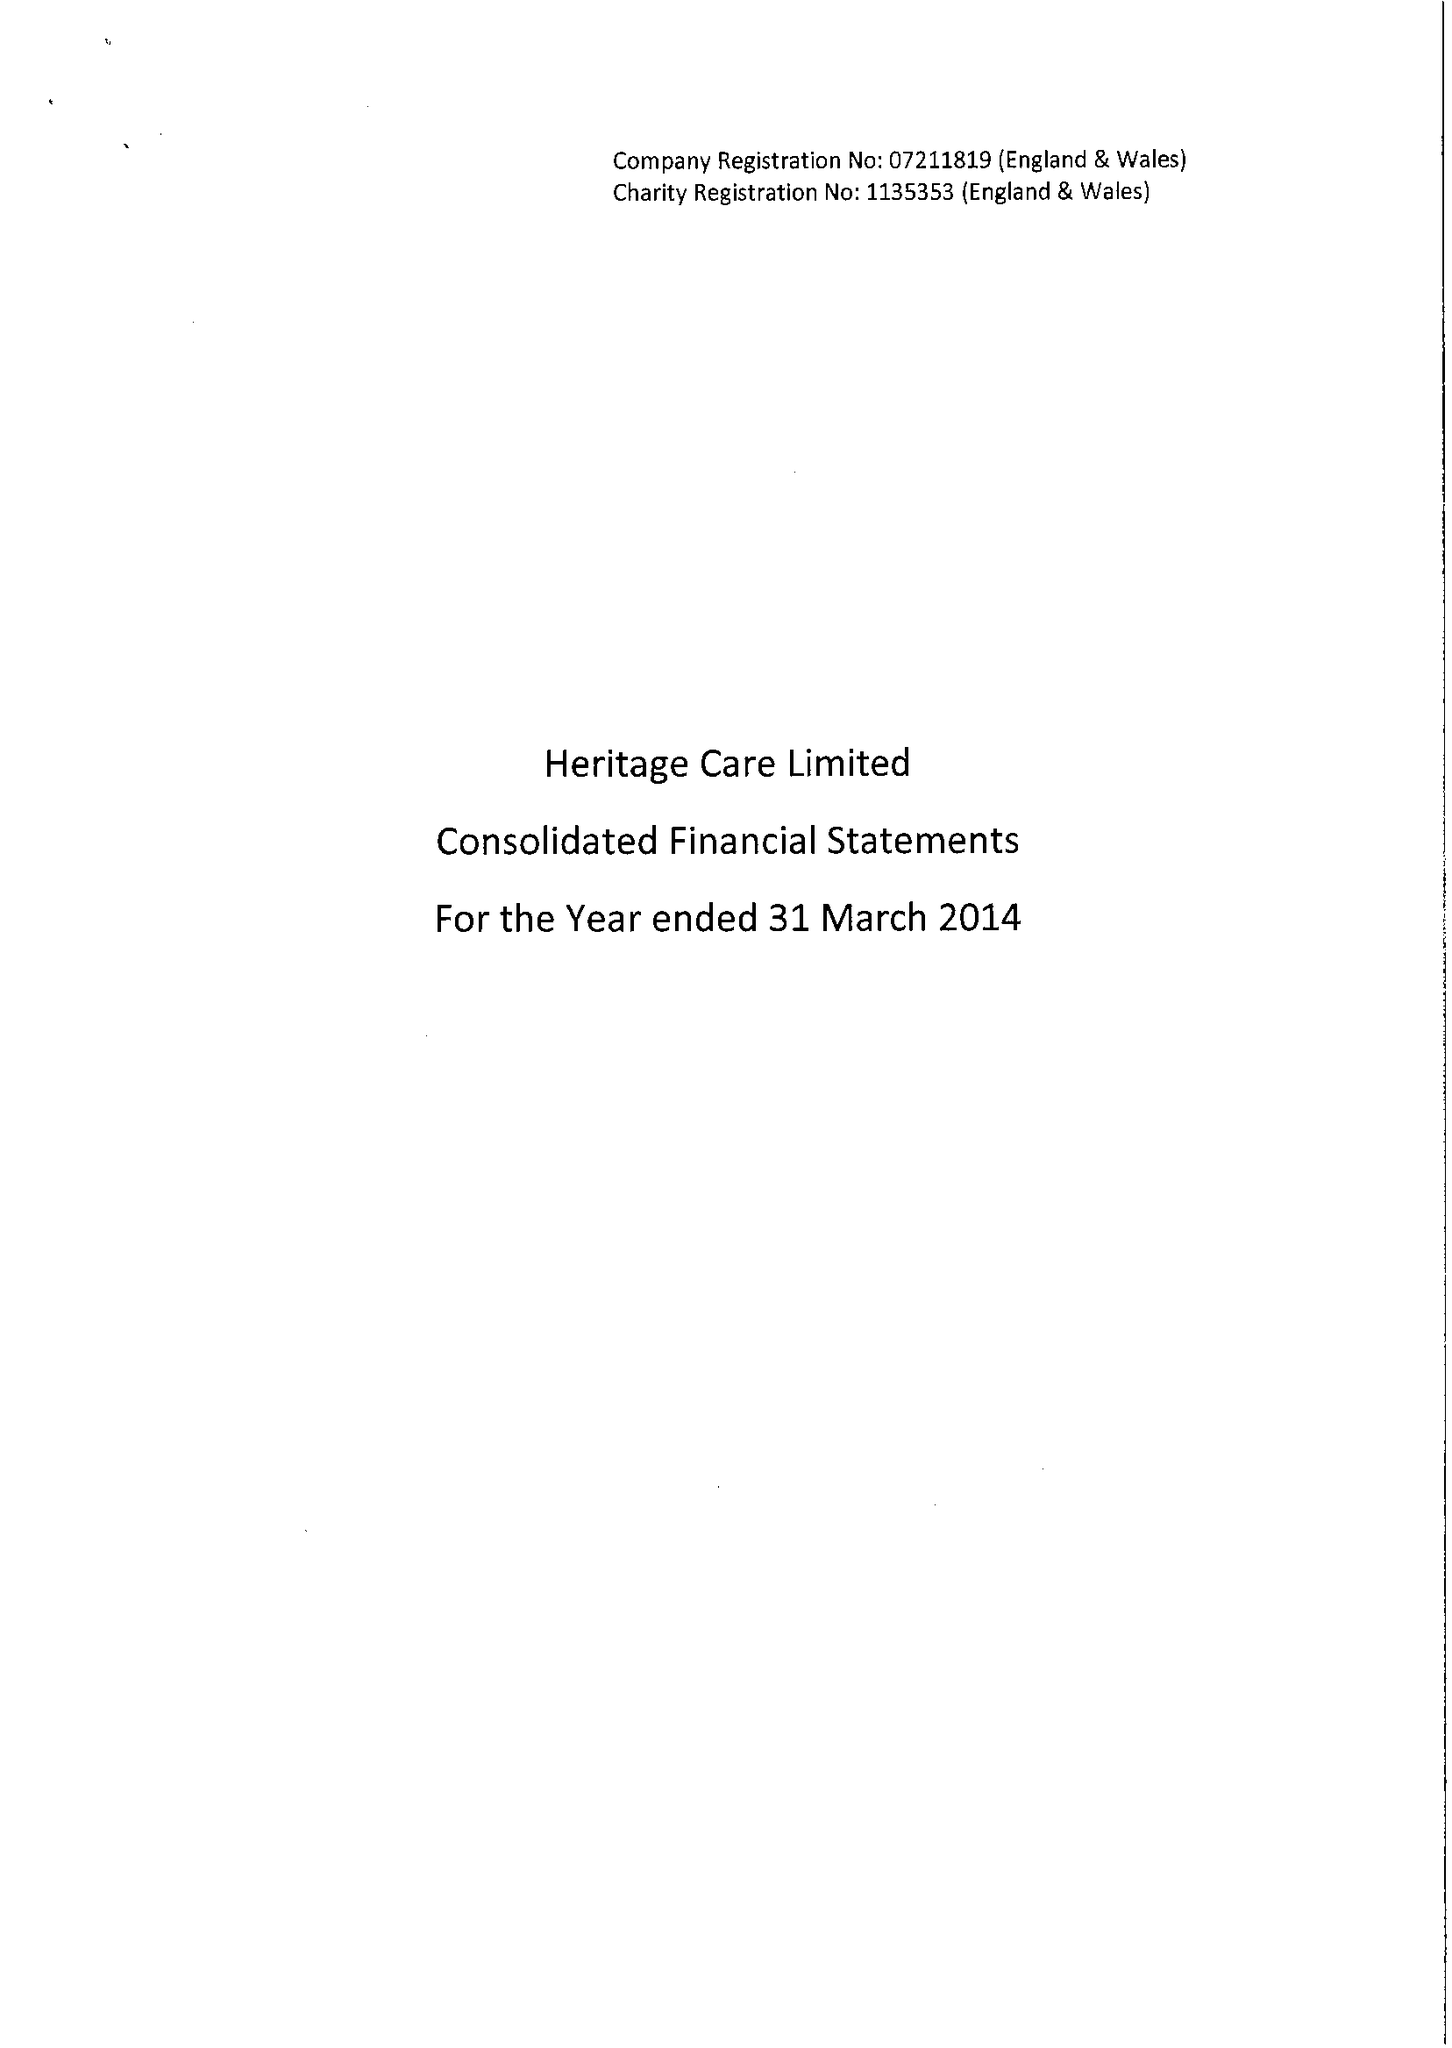What is the value for the charity_name?
Answer the question using a single word or phrase. Heritage Care Ltd. 